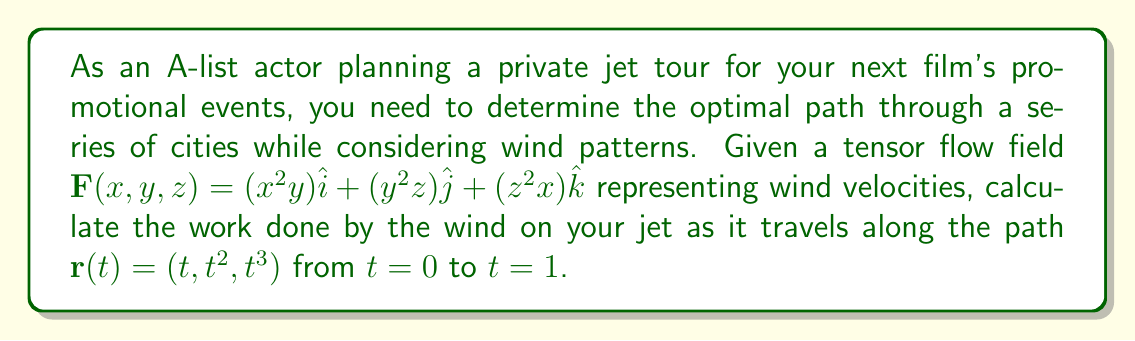Solve this math problem. To solve this problem, we'll follow these steps:

1) The work done by a vector field $\mathbf{F}$ along a path $\mathbf{r}(t)$ from $t=a$ to $t=b$ is given by the line integral:

   $$W = \int_a^b \mathbf{F}(\mathbf{r}(t)) \cdot \frac{d\mathbf{r}}{dt} dt$$

2) We're given $\mathbf{F}(x,y,z) = (x^2y)\hat{i} + (y^2z)\hat{j} + (z^2x)\hat{k}$ and $\mathbf{r}(t) = (t, t^2, t^3)$ from $t=0$ to $t=1$.

3) First, let's find $\frac{d\mathbf{r}}{dt}$:
   
   $$\frac{d\mathbf{r}}{dt} = (1, 2t, 3t^2)$$

4) Now, we need to evaluate $\mathbf{F}(\mathbf{r}(t))$:
   
   $$\mathbf{F}(\mathbf{r}(t)) = (t^2 \cdot t^2)\hat{i} + ((t^2)^2 \cdot t^3)\hat{j} + ((t^3)^2 \cdot t)\hat{k} = (t^4)\hat{i} + (t^7)\hat{j} + (t^7)\hat{k}$$

5) Now we can set up our integral:

   $$W = \int_0^1 [(t^4)(1) + (t^7)(2t) + (t^7)(3t^2)] dt$$

6) Simplify:

   $$W = \int_0^1 (t^4 + 2t^8 + 3t^9) dt$$

7) Integrate:

   $$W = [\frac{t^5}{5} + \frac{2t^9}{9} + \frac{3t^{10}}{10}]_0^1$$

8) Evaluate the integral:

   $$W = (\frac{1}{5} + \frac{2}{9} + \frac{3}{10}) - (0 + 0 + 0) = \frac{1}{5} + \frac{2}{9} + \frac{3}{10}$$

9) Simplify to a common denominator:

   $$W = \frac{18}{90} + \frac{20}{90} + \frac{27}{90} = \frac{65}{90}$$
Answer: $\frac{65}{90}$ 